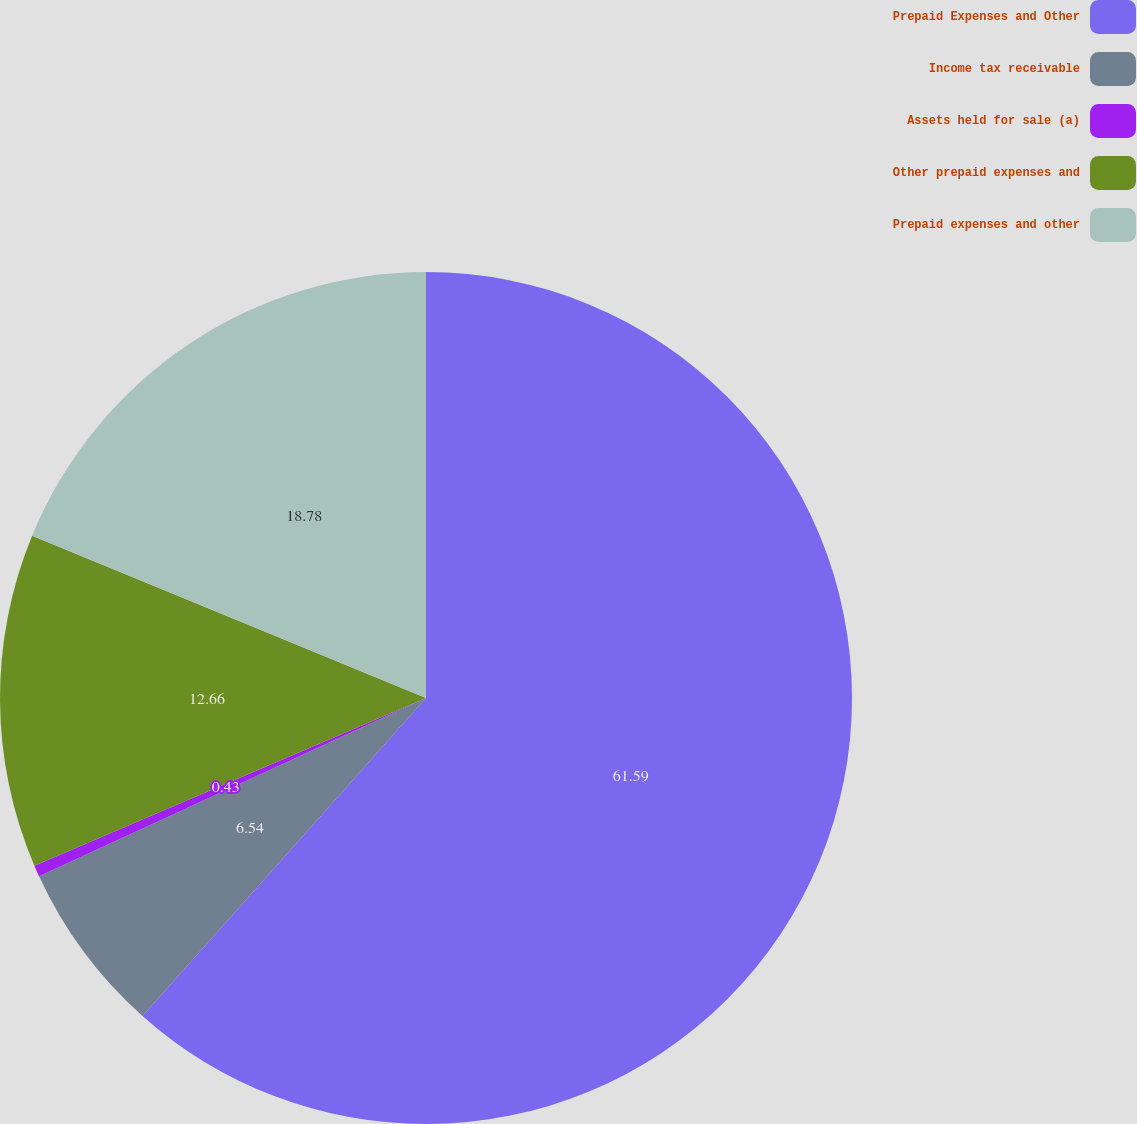Convert chart. <chart><loc_0><loc_0><loc_500><loc_500><pie_chart><fcel>Prepaid Expenses and Other<fcel>Income tax receivable<fcel>Assets held for sale (a)<fcel>Other prepaid expenses and<fcel>Prepaid expenses and other<nl><fcel>61.59%<fcel>6.54%<fcel>0.43%<fcel>12.66%<fcel>18.78%<nl></chart> 